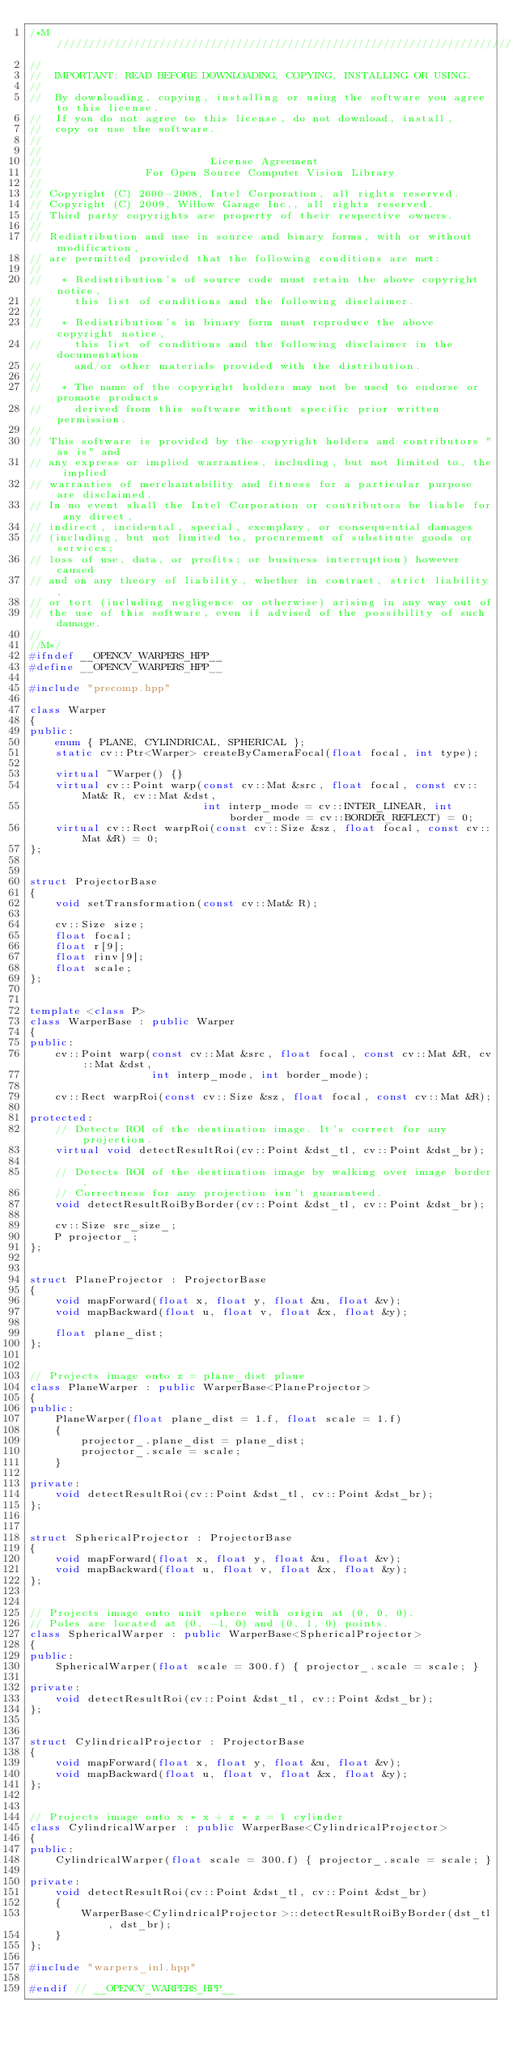<code> <loc_0><loc_0><loc_500><loc_500><_C++_>/*M///////////////////////////////////////////////////////////////////////////////////////
//
//  IMPORTANT: READ BEFORE DOWNLOADING, COPYING, INSTALLING OR USING.
//
//  By downloading, copying, installing or using the software you agree to this license.
//  If you do not agree to this license, do not download, install,
//  copy or use the software.
//
//
//                          License Agreement
//                For Open Source Computer Vision Library
//
// Copyright (C) 2000-2008, Intel Corporation, all rights reserved.
// Copyright (C) 2009, Willow Garage Inc., all rights reserved.
// Third party copyrights are property of their respective owners.
//
// Redistribution and use in source and binary forms, with or without modification,
// are permitted provided that the following conditions are met:
//
//   * Redistribution's of source code must retain the above copyright notice,
//     this list of conditions and the following disclaimer.
//
//   * Redistribution's in binary form must reproduce the above copyright notice,
//     this list of conditions and the following disclaimer in the documentation
//     and/or other materials provided with the distribution.
//
//   * The name of the copyright holders may not be used to endorse or promote products
//     derived from this software without specific prior written permission.
//
// This software is provided by the copyright holders and contributors "as is" and
// any express or implied warranties, including, but not limited to, the implied
// warranties of merchantability and fitness for a particular purpose are disclaimed.
// In no event shall the Intel Corporation or contributors be liable for any direct,
// indirect, incidental, special, exemplary, or consequential damages
// (including, but not limited to, procurement of substitute goods or services;
// loss of use, data, or profits; or business interruption) however caused
// and on any theory of liability, whether in contract, strict liability,
// or tort (including negligence or otherwise) arising in any way out of
// the use of this software, even if advised of the possibility of such damage.
//
//M*/
#ifndef __OPENCV_WARPERS_HPP__
#define __OPENCV_WARPERS_HPP__

#include "precomp.hpp"

class Warper
{
public:
    enum { PLANE, CYLINDRICAL, SPHERICAL };
    static cv::Ptr<Warper> createByCameraFocal(float focal, int type);

    virtual ~Warper() {}
    virtual cv::Point warp(const cv::Mat &src, float focal, const cv::Mat& R, cv::Mat &dst,
                           int interp_mode = cv::INTER_LINEAR, int border_mode = cv::BORDER_REFLECT) = 0;
    virtual cv::Rect warpRoi(const cv::Size &sz, float focal, const cv::Mat &R) = 0;
};


struct ProjectorBase
{
    void setTransformation(const cv::Mat& R);

    cv::Size size;
    float focal;
    float r[9];
    float rinv[9];
    float scale;
};


template <class P>
class WarperBase : public Warper
{   
public:
    cv::Point warp(const cv::Mat &src, float focal, const cv::Mat &R, cv::Mat &dst,
                   int interp_mode, int border_mode);

    cv::Rect warpRoi(const cv::Size &sz, float focal, const cv::Mat &R);

protected:
    // Detects ROI of the destination image. It's correct for any projection.
    virtual void detectResultRoi(cv::Point &dst_tl, cv::Point &dst_br);

    // Detects ROI of the destination image by walking over image border.
    // Correctness for any projection isn't guaranteed.
    void detectResultRoiByBorder(cv::Point &dst_tl, cv::Point &dst_br);

    cv::Size src_size_;
    P projector_;
};


struct PlaneProjector : ProjectorBase
{
    void mapForward(float x, float y, float &u, float &v);
    void mapBackward(float u, float v, float &x, float &y);

    float plane_dist;
};


// Projects image onto z = plane_dist plane
class PlaneWarper : public WarperBase<PlaneProjector>
{
public:
    PlaneWarper(float plane_dist = 1.f, float scale = 1.f)
    {
        projector_.plane_dist = plane_dist;
        projector_.scale = scale;
    }

private:
    void detectResultRoi(cv::Point &dst_tl, cv::Point &dst_br);
};


struct SphericalProjector : ProjectorBase
{
    void mapForward(float x, float y, float &u, float &v);
    void mapBackward(float u, float v, float &x, float &y);
};


// Projects image onto unit sphere with origin at (0, 0, 0).
// Poles are located at (0, -1, 0) and (0, 1, 0) points.
class SphericalWarper : public WarperBase<SphericalProjector>
{
public:
    SphericalWarper(float scale = 300.f) { projector_.scale = scale; }

private:  
    void detectResultRoi(cv::Point &dst_tl, cv::Point &dst_br);
};


struct CylindricalProjector : ProjectorBase
{
    void mapForward(float x, float y, float &u, float &v);
    void mapBackward(float u, float v, float &x, float &y);
};


// Projects image onto x * x + z * z = 1 cylinder
class CylindricalWarper : public WarperBase<CylindricalProjector>
{
public:
    CylindricalWarper(float scale = 300.f) { projector_.scale = scale; }

private:
    void detectResultRoi(cv::Point &dst_tl, cv::Point &dst_br)
    {
        WarperBase<CylindricalProjector>::detectResultRoiByBorder(dst_tl, dst_br);
    }
};

#include "warpers_inl.hpp"

#endif // __OPENCV_WARPERS_HPP__
</code> 